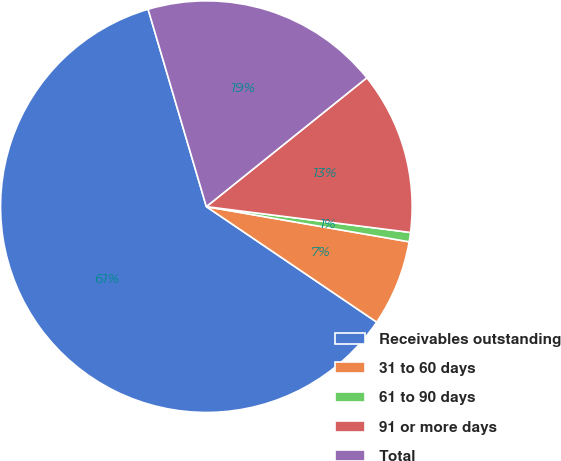Convert chart to OTSL. <chart><loc_0><loc_0><loc_500><loc_500><pie_chart><fcel>Receivables outstanding<fcel>31 to 60 days<fcel>61 to 90 days<fcel>91 or more days<fcel>Total<nl><fcel>60.95%<fcel>6.75%<fcel>0.73%<fcel>12.77%<fcel>18.8%<nl></chart> 